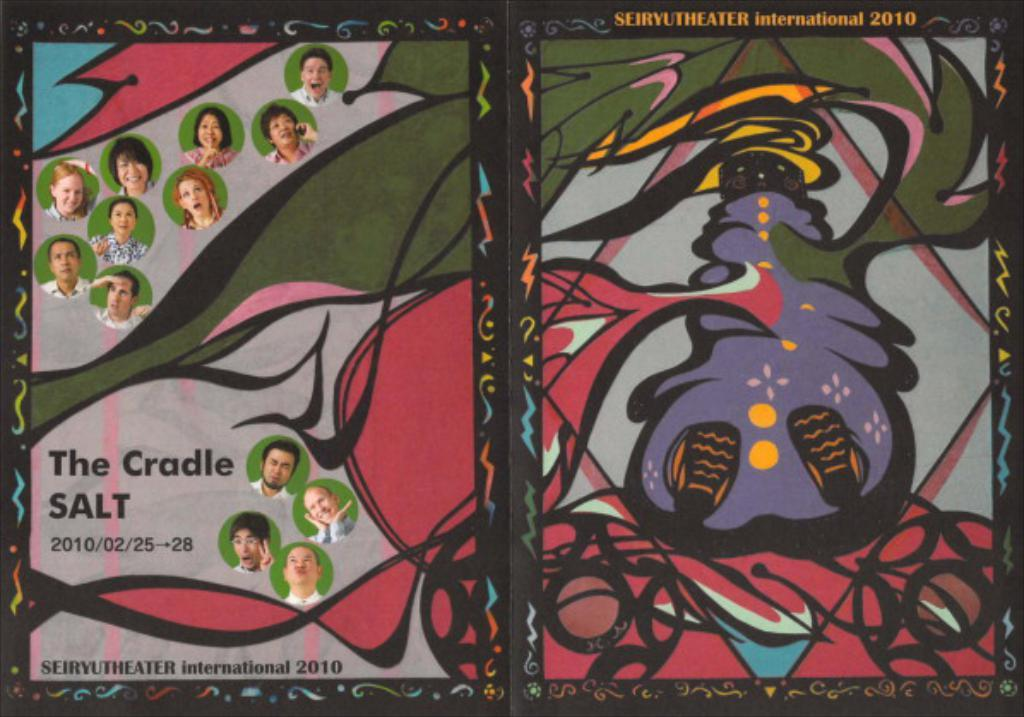What type of artwork is visible in the image? There is a painting and a drawing in the image. What else can be seen in the image besides the painting and drawing? There are many people's faces pasted on paper in the image. What type of holiday is being celebrated in the image? There is no indication of a holiday being celebrated in the image. How many women are present in the image? The provided facts do not mention the gender of the people whose faces are pasted on paper, so it cannot be determined how many women are present in the image. 